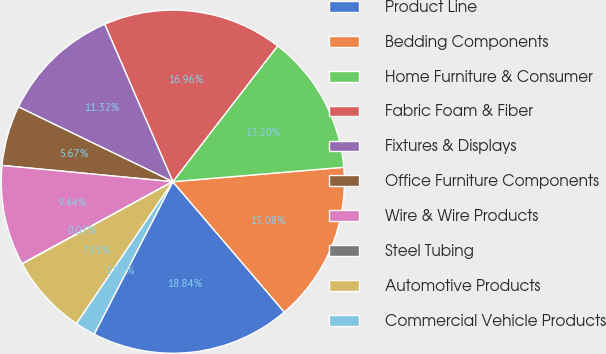Convert chart. <chart><loc_0><loc_0><loc_500><loc_500><pie_chart><fcel>Product Line<fcel>Bedding Components<fcel>Home Furniture & Consumer<fcel>Fabric Foam & Fiber<fcel>Fixtures & Displays<fcel>Office Furniture Components<fcel>Wire & Wire Products<fcel>Steel Tubing<fcel>Automotive Products<fcel>Commercial Vehicle Products<nl><fcel>18.84%<fcel>15.08%<fcel>13.2%<fcel>16.96%<fcel>11.32%<fcel>5.67%<fcel>9.44%<fcel>0.03%<fcel>7.55%<fcel>1.91%<nl></chart> 